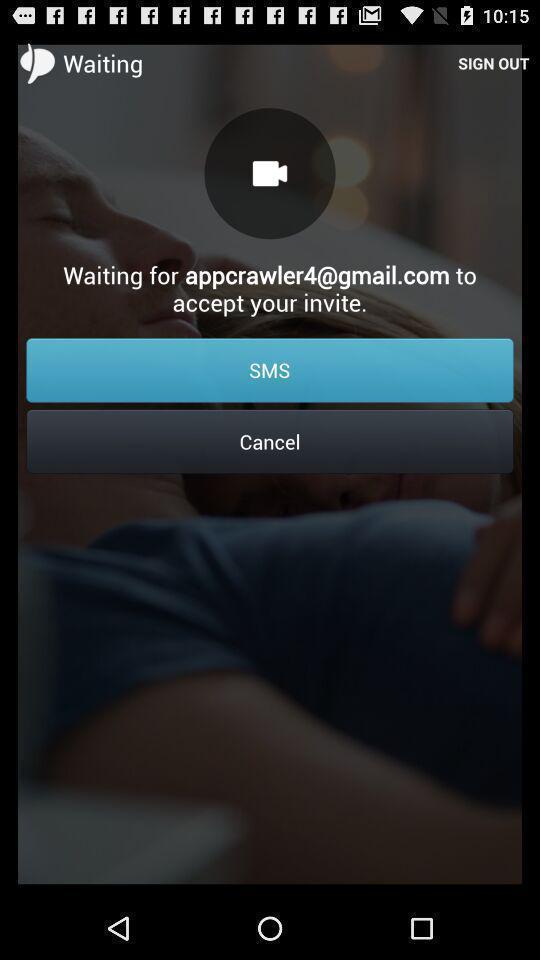Give me a summary of this screen capture. Waiting page for accepting invite. 